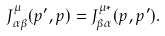Convert formula to latex. <formula><loc_0><loc_0><loc_500><loc_500>J ^ { \mu } _ { \alpha \beta } ( p ^ { \prime } , p ) = J ^ { \mu * } _ { \beta \alpha } ( p , p ^ { \prime } ) .</formula> 